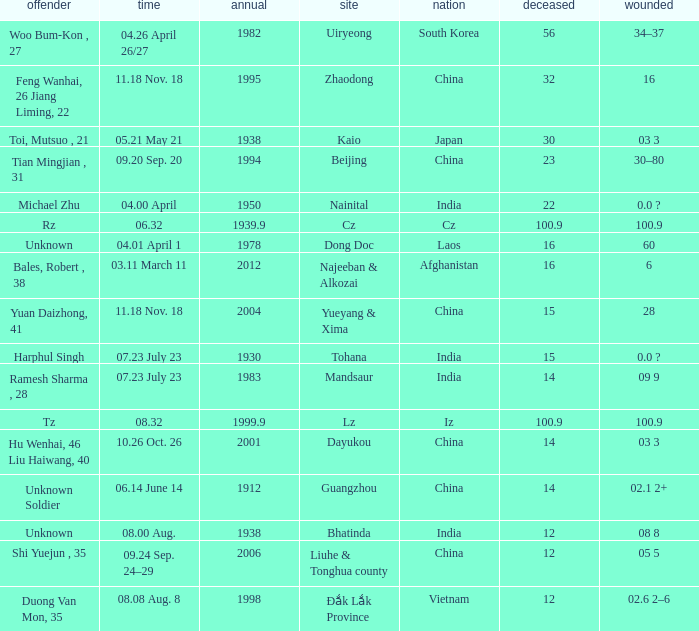What is the average Year, when Date is "04.01 April 1"? 1978.0. 